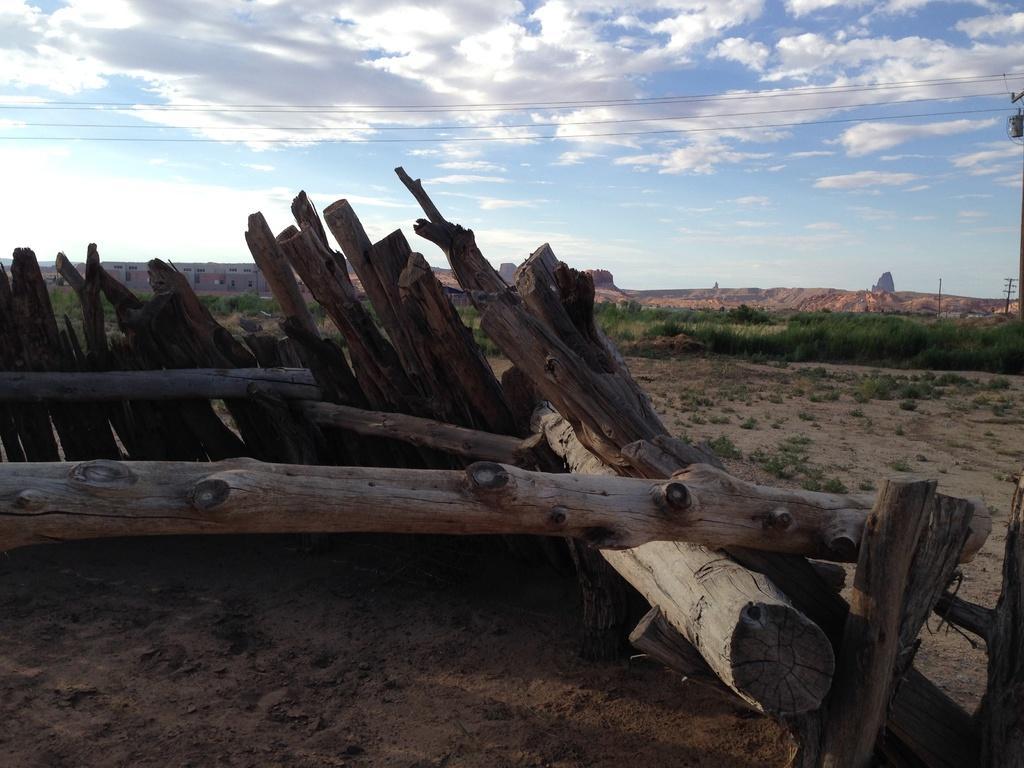Describe this image in one or two sentences. In the center of the image we can see a few wooden logs. In the background, we can see the sky, clouds, buildings, poles, wires, plants, grass and soil. 